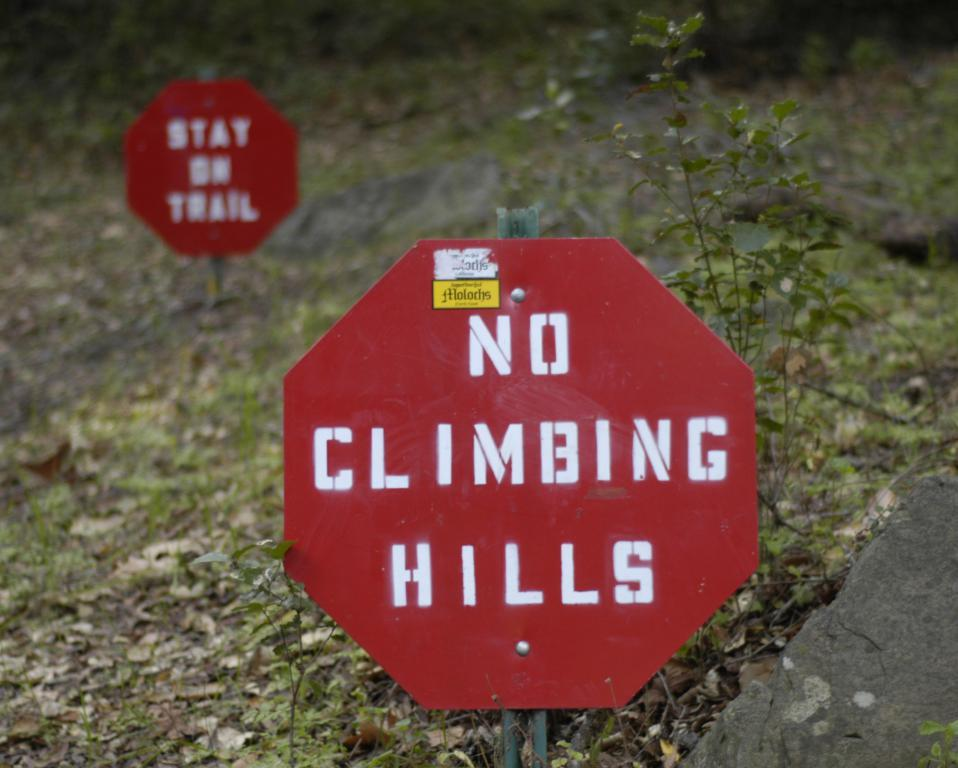What objects are on the ground in the image? There are name boards on the ground in the image. What type of natural element is present in the image? There is a stone in the image. What type of vegetation can be seen in the image? There are plants in the image. What type of ground cover is visible in the image? There is grass in the image. What type of shoe is visible on the stone in the image? There is no shoe present on the stone in the image. How many wings can be seen on the plants in the image? There are no wings present on the plants in the image. 